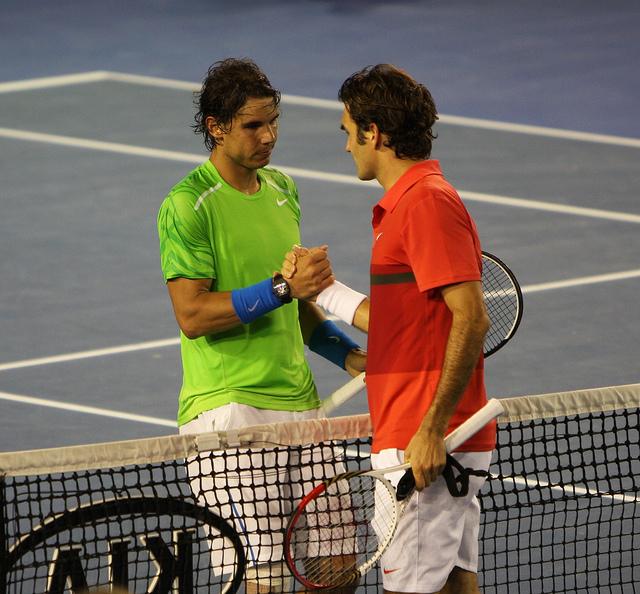Who is wearing a cap?
Answer briefly. No one. How many matches has these guys played?
Keep it brief. 1. Who sponsored this event?
Concise answer only. Kia. Are the men arm-wrestling?
Write a very short answer. No. Is this good sportsmanship?
Concise answer only. Yes. What is the color of the pitch?
Short answer required. Gray. Are the men blondes or brunettes?
Write a very short answer. Brunettes. 